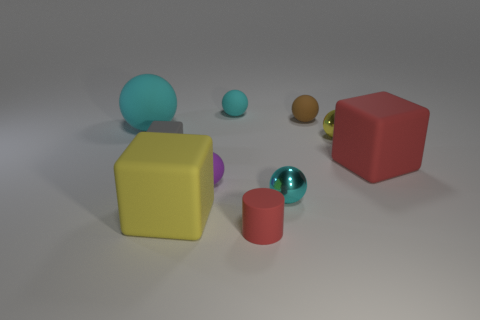What is the shape of the big matte object right of the red rubber object that is left of the small cyan metallic sphere?
Offer a terse response. Cube. Are there any small cyan objects that have the same shape as the brown object?
Provide a succinct answer. Yes. There is a cyan metal thing that is the same size as the purple rubber object; what is its shape?
Your response must be concise. Sphere. There is a block right of the small cyan thing in front of the small brown ball; is there a block that is in front of it?
Provide a short and direct response. Yes. Is there a cyan rubber sphere that has the same size as the red cylinder?
Your answer should be very brief. Yes. There is a cyan ball that is in front of the large red rubber cube; how big is it?
Your answer should be very brief. Small. The big cube in front of the shiny ball that is in front of the large thing to the right of the big yellow rubber thing is what color?
Provide a succinct answer. Yellow. The block that is right of the yellow object that is behind the purple thing is what color?
Give a very brief answer. Red. Is the number of large objects right of the red matte cylinder greater than the number of big cyan rubber spheres in front of the small yellow thing?
Keep it short and to the point. Yes. Is the cyan ball in front of the large cyan ball made of the same material as the object that is left of the tiny gray rubber thing?
Offer a terse response. No. 